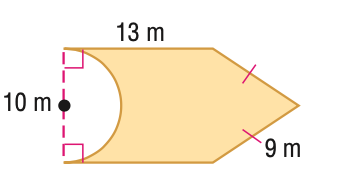Answer the mathemtical geometry problem and directly provide the correct option letter.
Question: Find the area of the figure. Round to the nearest tenth if necessary.
Choices: A: 88.9 B: 128.1 C: 165.6 D: 206.7 B 